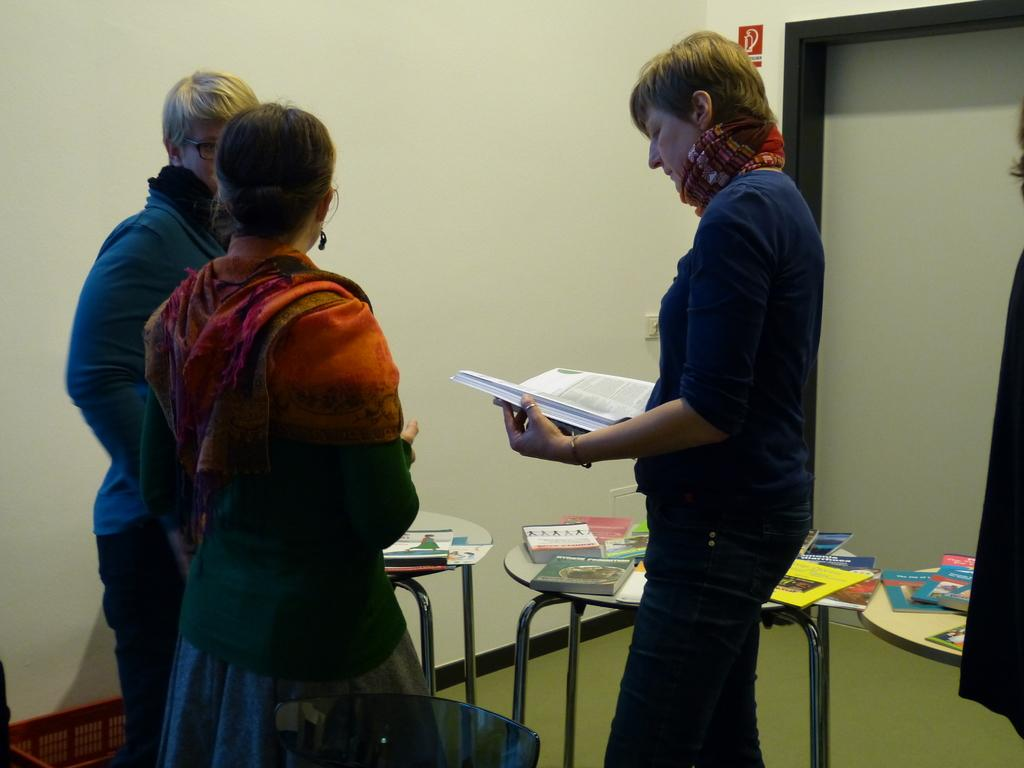How many people are in the room in the image? There are three people standing in the room. What is one person holding in the image? One person is holding a book. What can be found on the table in the image? There are books on the table. What type of rock can be seen on the floor in the image? There is no rock present on the floor in the image. What type of pleasure can be experienced by the people in the image? The image does not provide information about the emotions or experiences of the people, so it cannot be determined what type of pleasure they might be experiencing. 